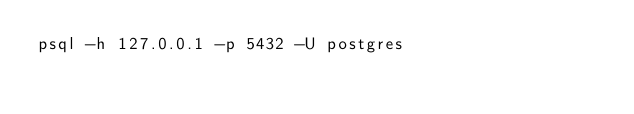Convert code to text. <code><loc_0><loc_0><loc_500><loc_500><_Bash_>psql -h 127.0.0.1 -p 5432 -U postgres
</code> 